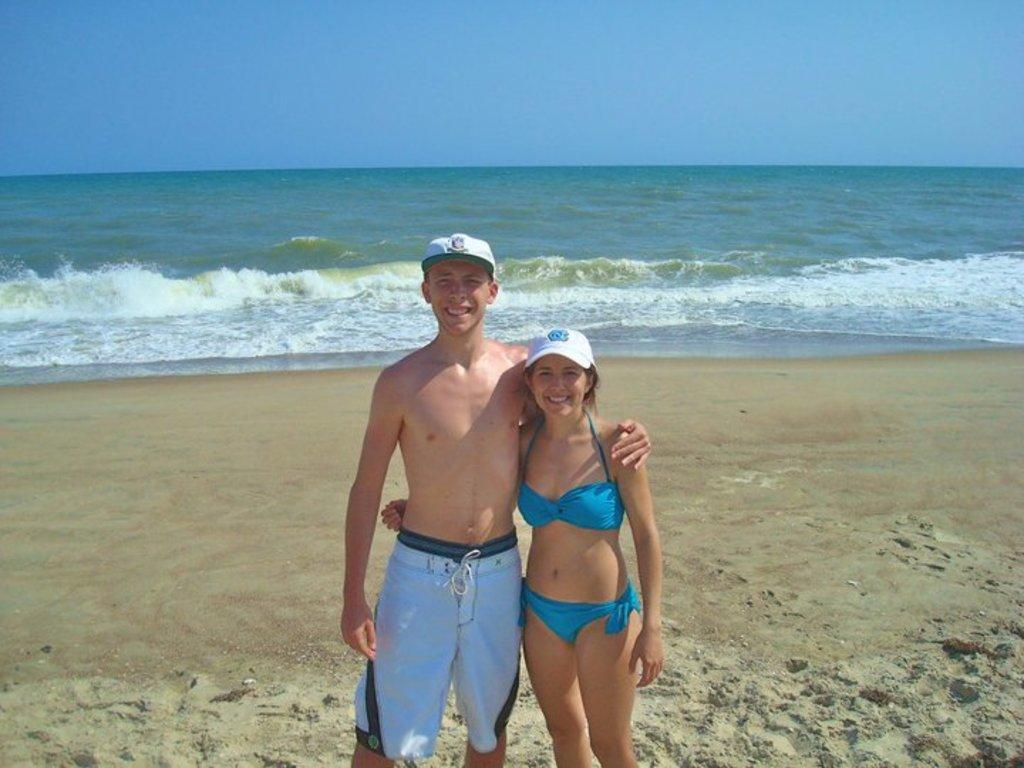How many people are in the image? There are two people in the image. What are the two people doing in the image? The two people are posing for a photo. What type of surface are the two people standing on? The two people are standing on sand. What can be seen in the background of the image? There is a sea visible in the image. What type of education can be seen taking place in the image? There is no education taking place in the image; it features two people posing for a photo on sand near a sea. What type of thrill can be seen being experienced by the two people in the image? There is no thrill being experienced by the two people in the image; they are simply posing for a photo. 